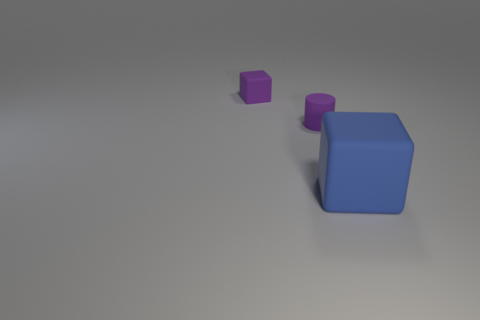What number of small rubber things have the same color as the tiny rubber cube?
Keep it short and to the point. 1. How many objects are rubber things on the left side of the large cube or tiny purple matte objects to the right of the purple block?
Ensure brevity in your answer.  2. Is the number of small purple cylinders on the left side of the tiny purple cylinder less than the number of big red rubber cylinders?
Keep it short and to the point. No. Are there any red metallic cubes that have the same size as the cylinder?
Give a very brief answer. No. The tiny block is what color?
Make the answer very short. Purple. Do the purple cylinder and the purple matte block have the same size?
Ensure brevity in your answer.  Yes. How many things are either blue cubes or big purple shiny cylinders?
Keep it short and to the point. 1. Are there the same number of purple cylinders behind the small block and tiny green shiny cubes?
Offer a very short reply. Yes. Is there a small object that is in front of the cube to the right of the cube that is behind the blue matte object?
Give a very brief answer. No. There is a small cylinder that is the same material as the big cube; what is its color?
Provide a succinct answer. Purple. 